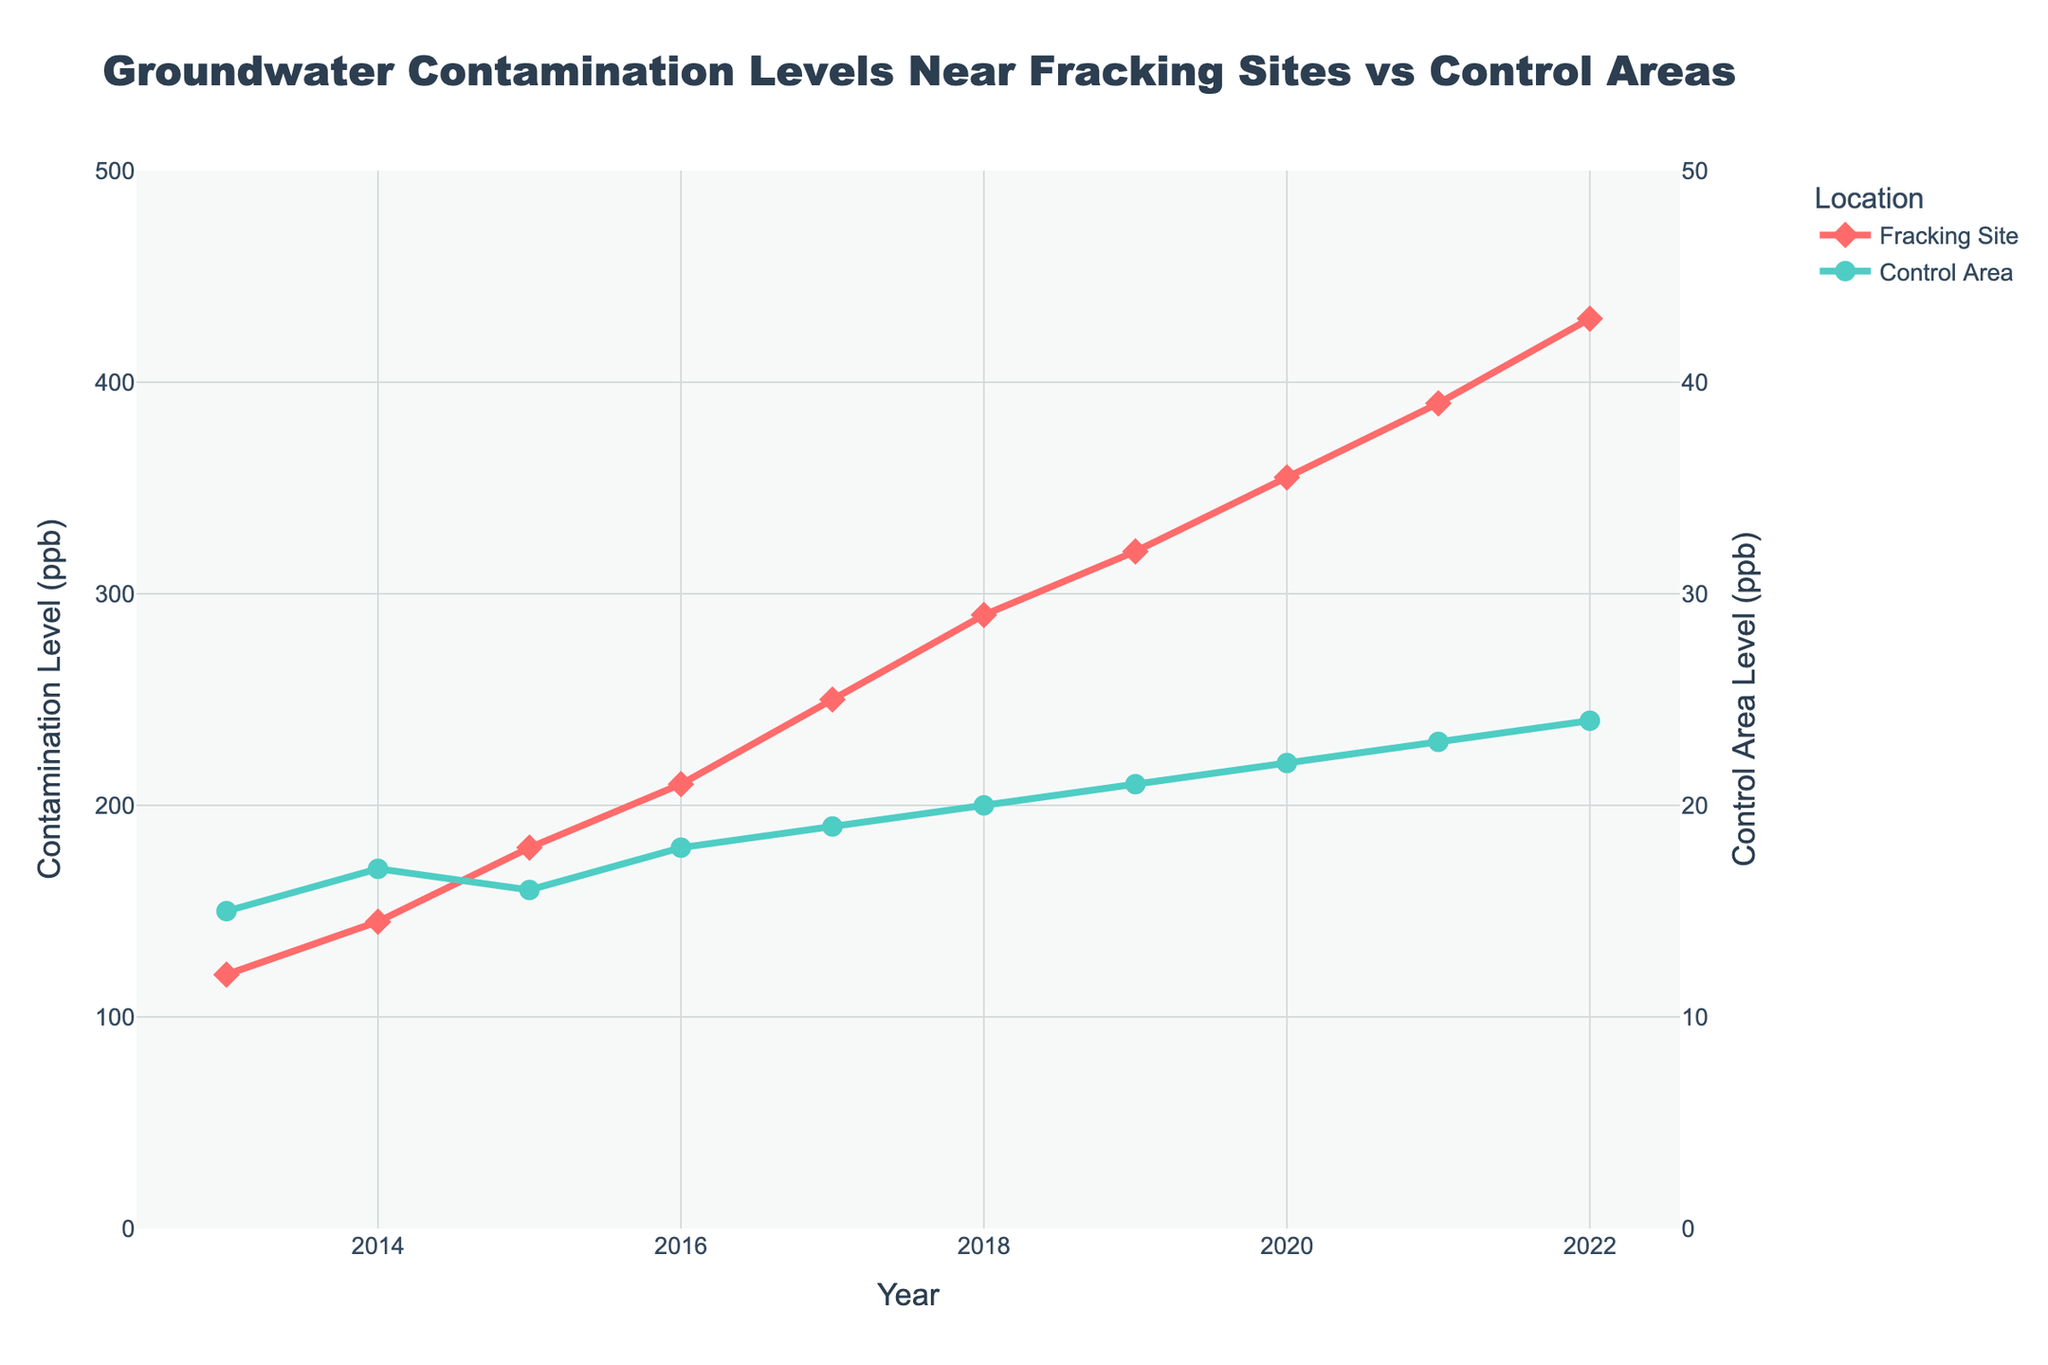How does the contamination level at fracking sites in 2013 compare to the control area in the same year? The figure shows that in 2013, the contamination level at fracking sites is marked with red diamonds, and the control area is marked with green circles. In 2013, the contamination level at fracking sites is 120 ppb, and at the control area, it is 15 ppb.
Answer: The contamination level at fracking sites is higher by 105 ppb Over the 10-year period, which year experienced the highest increase in contamination levels at fracking sites compared to the previous year? To answer this, we look at the difference in contamination levels at fracking sites year over year from 2013 to 2022. The highest increase can be found by comparing the year-to-year differences. The largest difference is from 2021 to 2022, where it increased from 390 ppb to 430 ppb, a rise of 40 ppb.
Answer: 2022 What is the average contamination level at fracking sites over the 10-year period? The contamination levels at fracking sites over the 10 years are: 120, 145, 180, 210, 250, 290, 320, 355, 390, and 430 ppb. Sum these values and divide by 10. The sum is 2690 and dividing by 10 gives an average level.
Answer: 269 Compare the trends in contamination levels between fracking sites and control areas from 2013 to 2022. What do you observe? Observing the trends in the figure, the contamination levels at fracking sites show a steady increase each year. In contrast, the contamination levels in control areas also increase but at a much slower rate. This indicates that the rate of increase in contamination at fracking sites is significantly higher compared to control areas.
Answer: Contamination levels at fracking sites increase much faster What was the contamination level difference between fracking sites and control areas in 2020? From the figure, in 2020, the contamination level at fracking sites is 355 ppb, and at control areas, it is 22 ppb. The difference is calculated by subtracting 22 from 355.
Answer: 333 ppb If the contamination level at fracking sites continues to increase by the largest observed annual increment from previous years, what will the level be in 2023? The largest observed annual increment is 40 ppb (from 2021 to 2022). If this trend continues, the contamination level in fracking sites in 2023 will be 430 + 40 ppb.
Answer: 470 ppb Which year's contamination level at fracking sites most closely matches the maximum contamination level at the control areas? The maximum contamination level at control areas in 2022 is 24 ppb. The closest contamination level at fracking sites to this value is in 2013, which is 120 ppb and is much higher. Therefore, no year closely matches the maximum level of 24 ppb at the control areas.
Answer: No close match By how much did the contamination level in control areas increase over the 10-year period? From the figure, the contamination level in control areas increased from 15 ppb in 2013 to 24 ppb in 2022. The increase is calculated by subtracting 15 from 24.
Answer: 9 ppb 